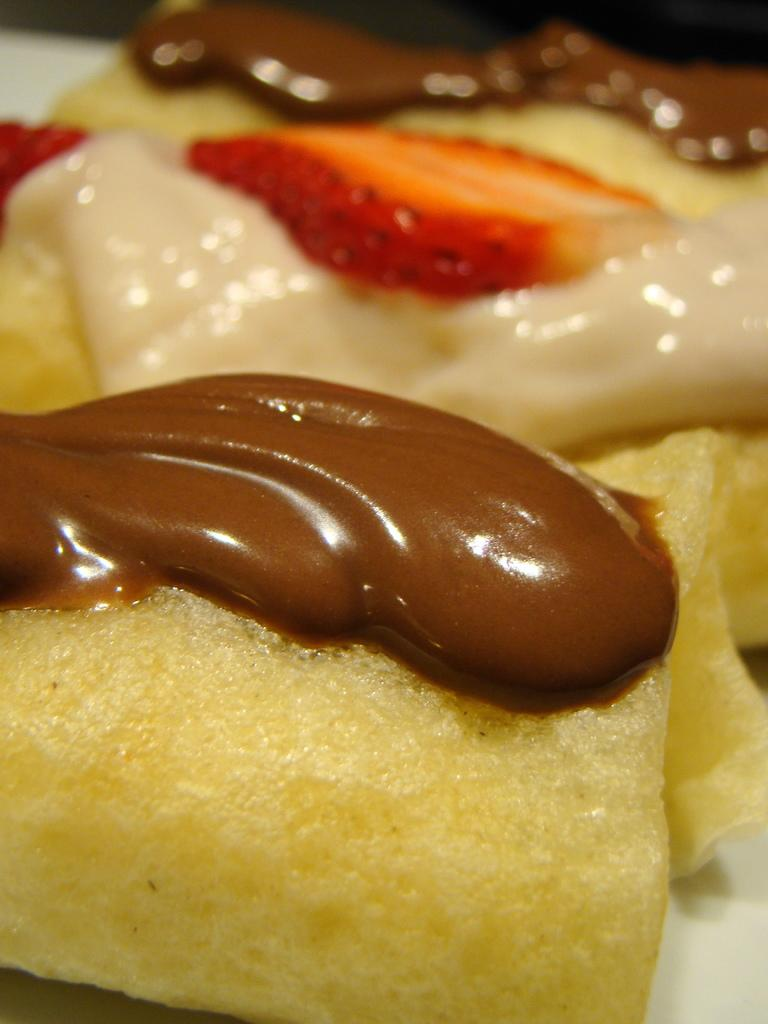What is the main subject of the image? There is a food item in the image. Can you describe the surface on which the food item is placed? The food item is on a white color surface. What country is depicted in the background of the image? There is no country depicted in the image, as it only features a food item on a white surface. Can you tell me how many pickles are on the food item? There is no mention of pickles in the image, as it only features a food item on a white surface. 